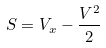<formula> <loc_0><loc_0><loc_500><loc_500>S = V _ { x } - \frac { V ^ { 2 } } { 2 }</formula> 